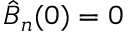Convert formula to latex. <formula><loc_0><loc_0><loc_500><loc_500>\hat { B } _ { n } ( 0 ) = 0</formula> 